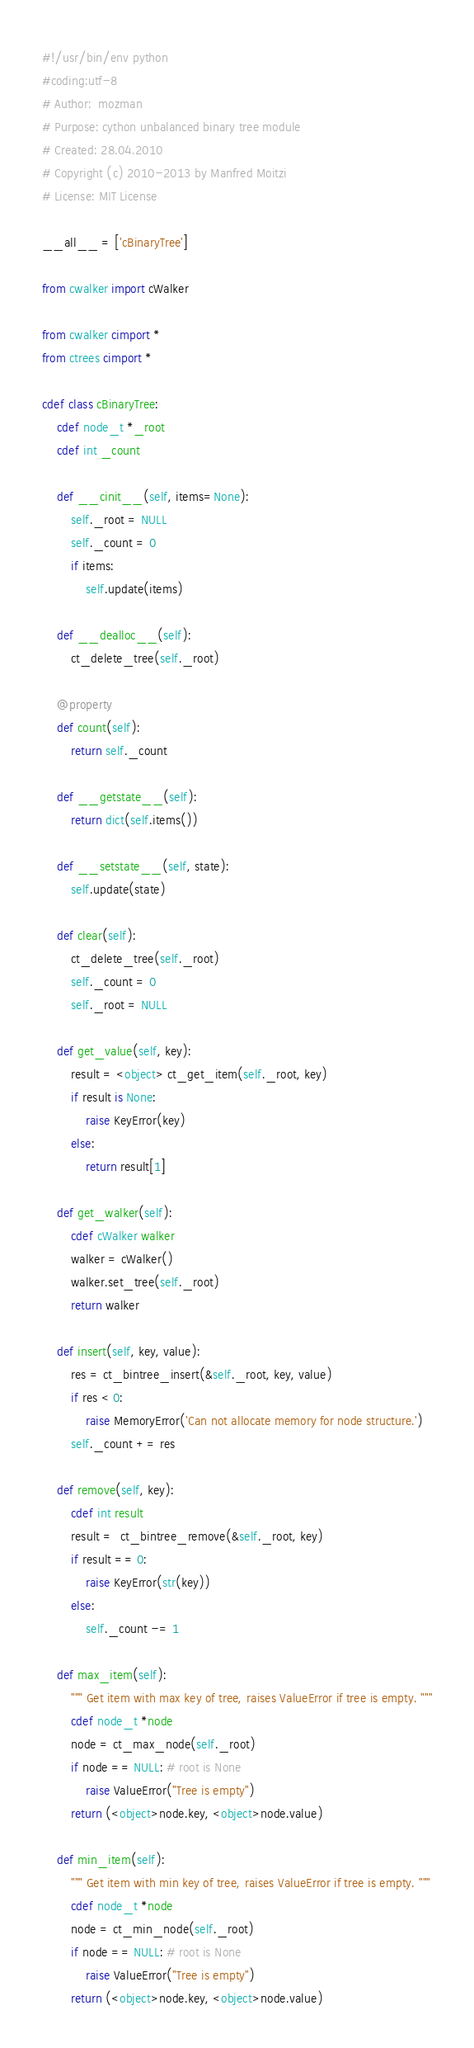Convert code to text. <code><loc_0><loc_0><loc_500><loc_500><_Cython_>#!/usr/bin/env python
#coding:utf-8
# Author:  mozman
# Purpose: cython unbalanced binary tree module
# Created: 28.04.2010
# Copyright (c) 2010-2013 by Manfred Moitzi
# License: MIT License

__all__ = ['cBinaryTree']

from cwalker import cWalker

from cwalker cimport *
from ctrees cimport *

cdef class cBinaryTree:
    cdef node_t *_root
    cdef int _count

    def __cinit__(self, items=None):
        self._root = NULL
        self._count = 0
        if items:
            self.update(items)

    def __dealloc__(self):
        ct_delete_tree(self._root)

    @property
    def count(self):
        return self._count

    def __getstate__(self):
        return dict(self.items())

    def __setstate__(self, state):
        self.update(state)

    def clear(self):
        ct_delete_tree(self._root)
        self._count = 0
        self._root = NULL

    def get_value(self, key):
        result = <object> ct_get_item(self._root, key)
        if result is None:
            raise KeyError(key)
        else:
            return result[1]

    def get_walker(self):
        cdef cWalker walker
        walker = cWalker()
        walker.set_tree(self._root)
        return walker

    def insert(self, key, value):
        res = ct_bintree_insert(&self._root, key, value)
        if res < 0:
            raise MemoryError('Can not allocate memory for node structure.')
        self._count += res

    def remove(self, key):
        cdef int result
        result =  ct_bintree_remove(&self._root, key)
        if result == 0:
            raise KeyError(str(key))
        else:
            self._count -= 1

    def max_item(self):
        """ Get item with max key of tree, raises ValueError if tree is empty. """
        cdef node_t *node
        node = ct_max_node(self._root)
        if node == NULL: # root is None
            raise ValueError("Tree is empty")
        return (<object>node.key, <object>node.value)

    def min_item(self):
        """ Get item with min key of tree, raises ValueError if tree is empty. """
        cdef node_t *node
        node = ct_min_node(self._root)
        if node == NULL: # root is None
            raise ValueError("Tree is empty")
        return (<object>node.key, <object>node.value)
</code> 